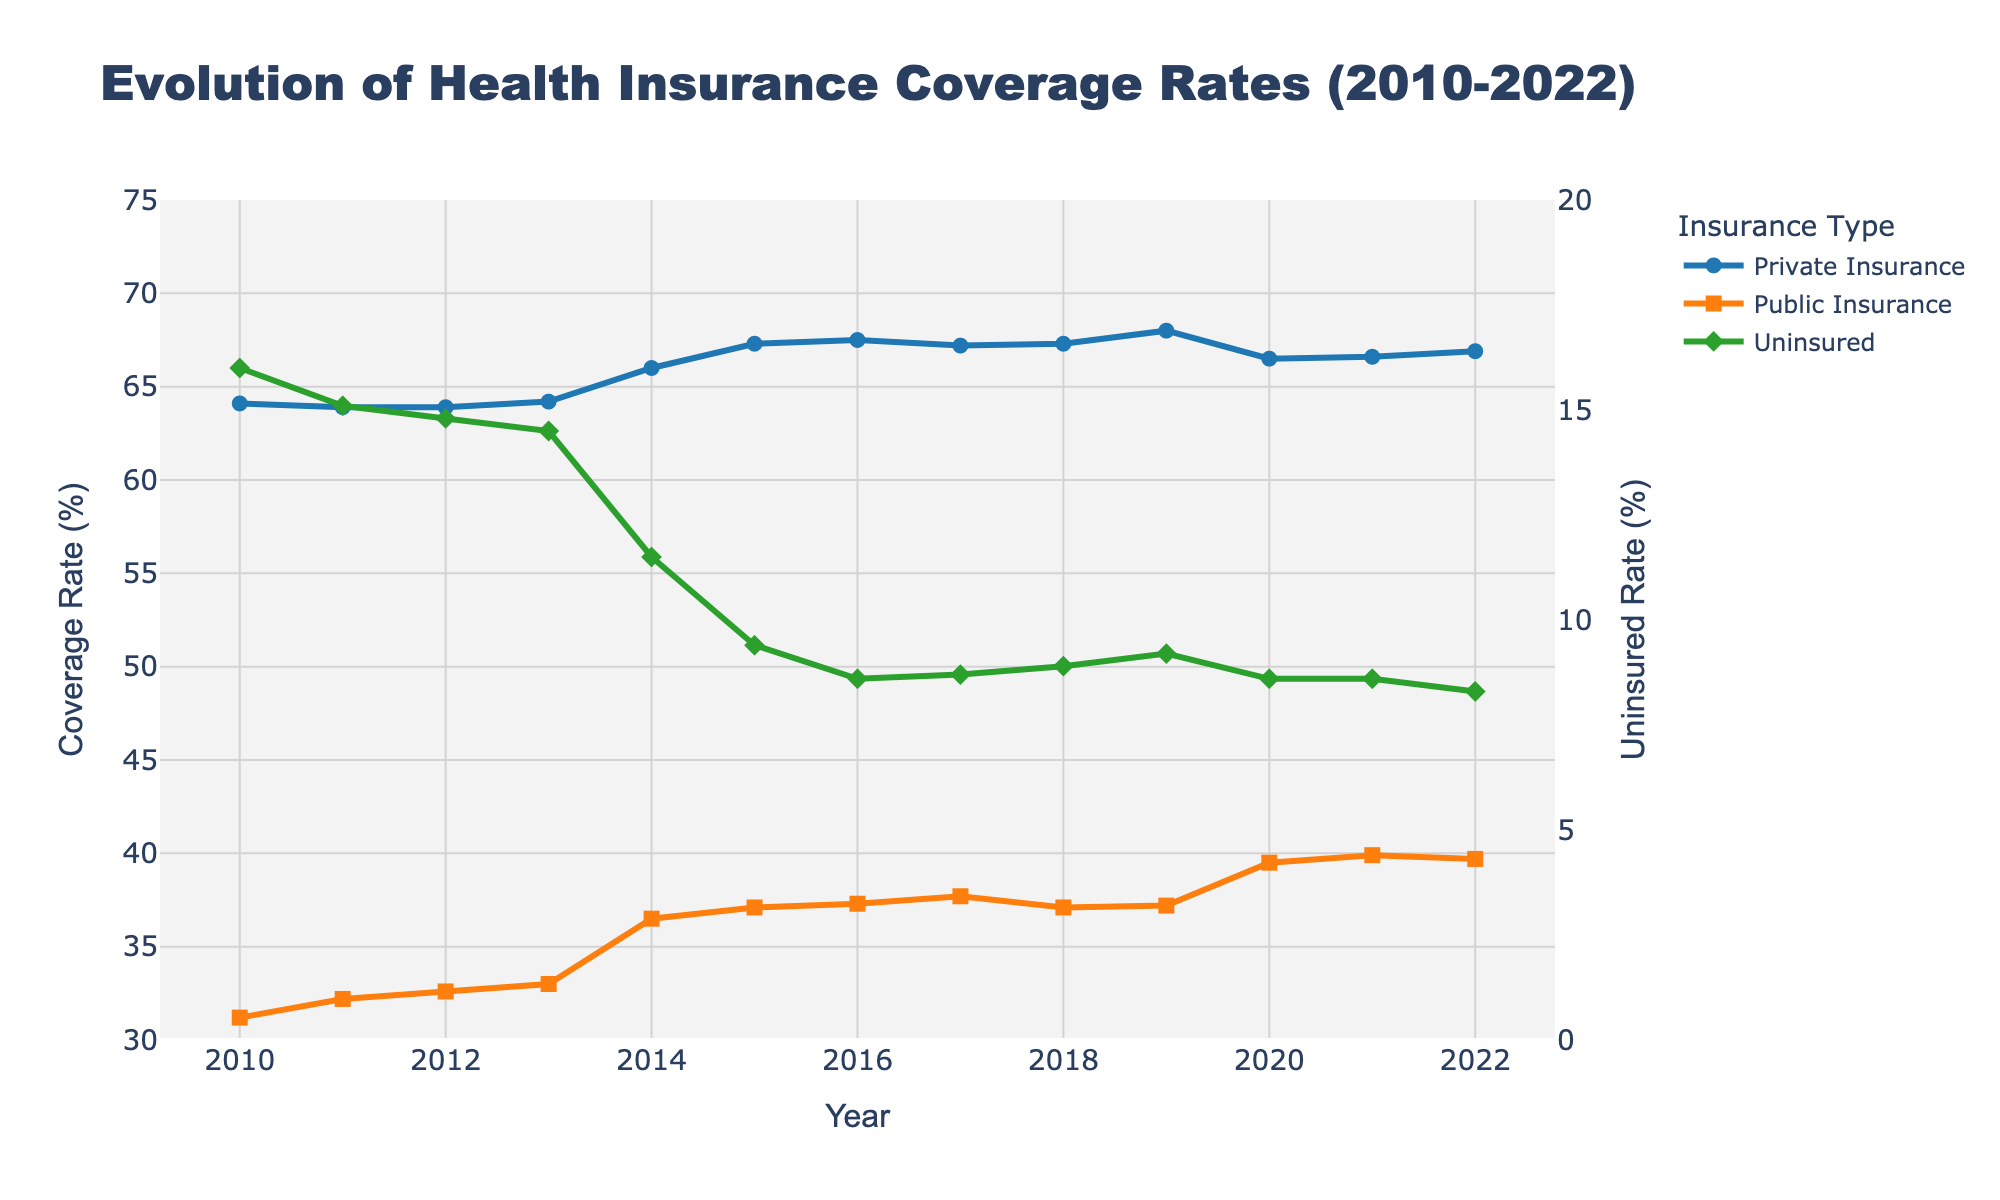Which insurance type had the highest coverage rate in 2022? Looking at the 2022 data points, the private insurance line is the highest among the three types.
Answer: Private Insurance How did the coverage rate for uninsured individuals change from 2010 to 2022? Calculate the difference between the values in 2010 (16.0%) and 2022 (8.3%). The uninsured rate decreased over these years.
Answer: Decreased by 7.7 percentage points In which year did public insurance see the largest increase in coverage rate? Observing the public insurance line, the largest increase occurred between 2013 (33.0%) and 2014 (36.5%).
Answer: 2014 What are the three years with the lowest uninsured rates? Visually find the lowest points on the uninsured line, they are in 2016 (8.6%), 2020 (8.6%), and 2022 (8.3%).
Answer: 2016, 2020, 2022 In 2015, which insurance type covered the most people, and what was the coverage rate? The private insurance line is higher than public insurance in 2015. The coverage rate for private insurance in that year is 67.3%.
Answer: Private Insurance, 67.3% What was the combined coverage rate for private and public insurance in 2014? Add the rates for private (66.0%) and public (36.5%) insurance in 2014. 66.0% + 36.5% = 102.5%
Answer: 102.5% Between private and public insurance, which saw more consistent coverage rates over the years? The private insurance line is more consistent, showing less fluctuation compared to the public insurance line.
Answer: Private Insurance How did the uninsured rate in 2016 compare to the uninsured rate in 2014? Uninsured rate in 2016 (8.6%) is lower than in 2014 (11.5%).
Answer: Lower by 2.9 percentage points Which year had the highest public insurance coverage rate? The highest point on the public insurance line is in 2021 with a rate of 39.9%.
Answer: 2021 By how much did the coverage rate for private insurance increase from 2013 to 2019? The increase from 2013 (64.2%) to 2019 (68.0%) is 68.0% - 64.2% = 3.8 percentage points.
Answer: Increased by 3.8 percentage points 